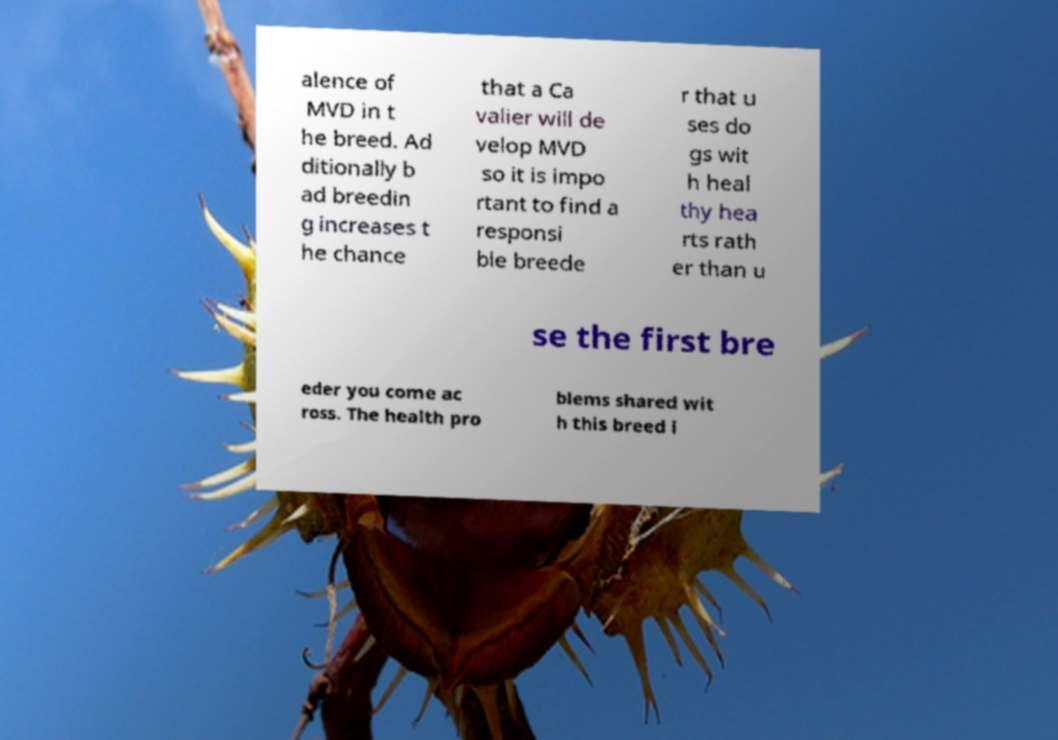I need the written content from this picture converted into text. Can you do that? alence of MVD in t he breed. Ad ditionally b ad breedin g increases t he chance that a Ca valier will de velop MVD so it is impo rtant to find a responsi ble breede r that u ses do gs wit h heal thy hea rts rath er than u se the first bre eder you come ac ross. The health pro blems shared wit h this breed i 